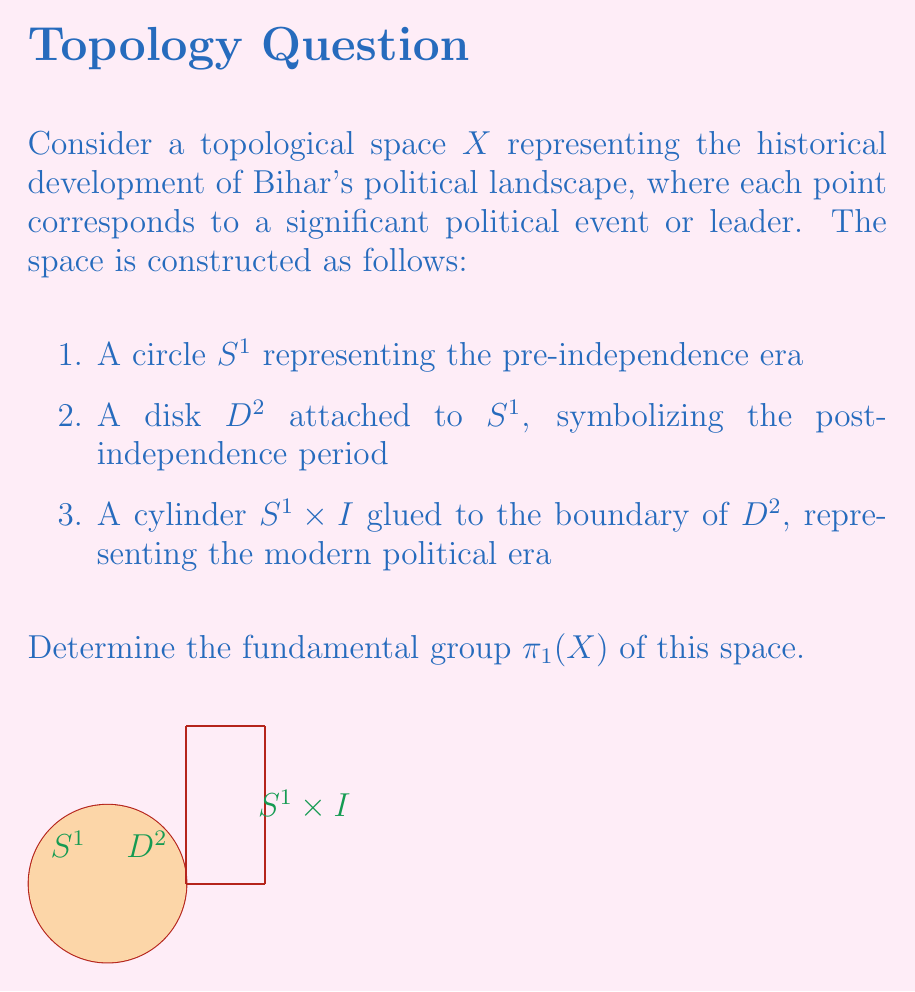Could you help me with this problem? To find the fundamental group of $X$, we'll use the following steps:

1) First, observe that $X$ is constructed by attaching a disk $D^2$ to a circle $S^1$, and then attaching a cylinder $S^1 \times I$ to the resulting space.

2) The attachment of $D^2$ to $S^1$ forms a space homotopy equivalent to a point. This is because the disk $D^2$ can be continuously shrunk to a point on $S^1$.

3) The cylinder $S^1 \times I$ is homotopy equivalent to $S^1$. When attached to the previous space (which is contractible), it essentially determines the fundamental group of the entire space.

4) Therefore, $X$ is homotopy equivalent to $S^1$.

5) We know that the fundamental group of $S^1$ is isomorphic to the integers under addition, i.e., $\pi_1(S^1) \cong \mathbb{Z}$.

6) Since homotopy equivalent spaces have isomorphic fundamental groups, we can conclude that $\pi_1(X) \cong \pi_1(S^1) \cong \mathbb{Z}$.

This result suggests that the political landscape of Bihar, despite its complexities, has a cyclic nature in its fundamental structure, possibly reflecting recurring themes or patterns in its political history.
Answer: $\pi_1(X) \cong \mathbb{Z}$ 